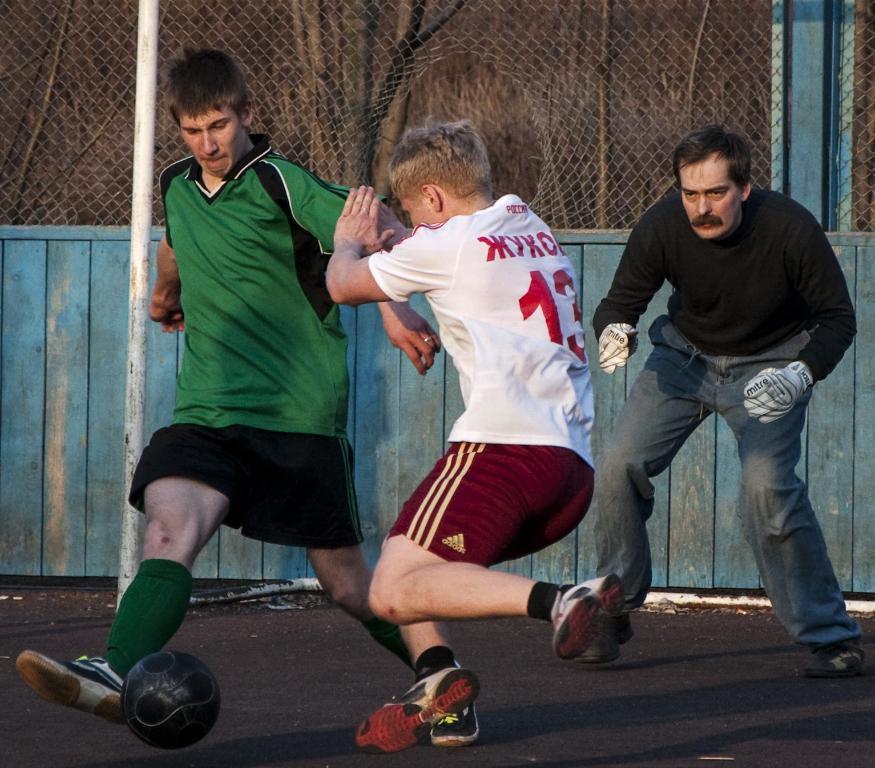How would you summarize this image in a sentence or two? Two boys playing football and the referee in the back side watching them in play field surrounded by fence. 